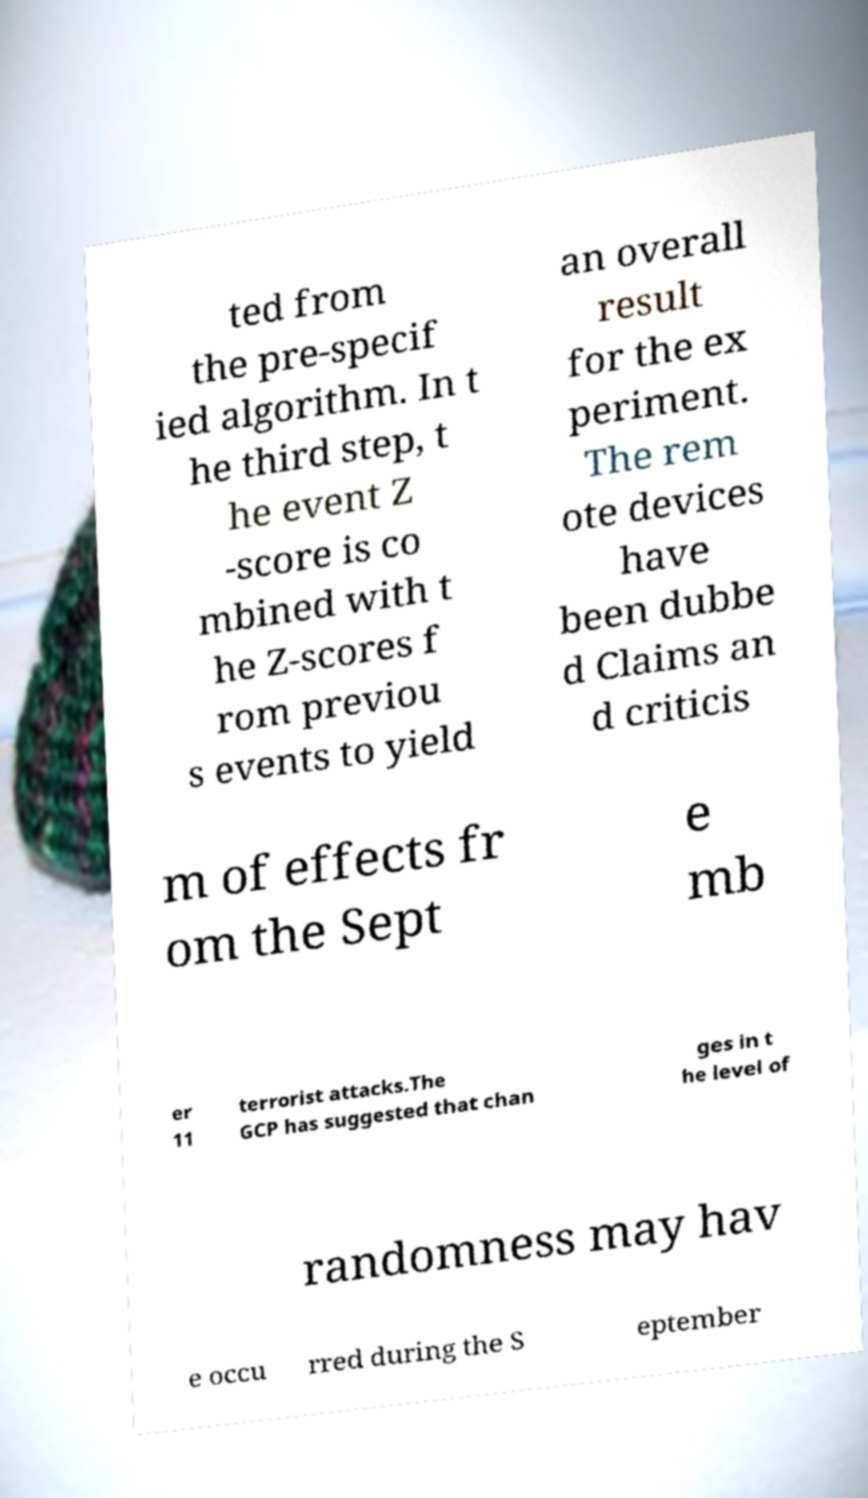Please identify and transcribe the text found in this image. ted from the pre-specif ied algorithm. In t he third step, t he event Z -score is co mbined with t he Z-scores f rom previou s events to yield an overall result for the ex periment. The rem ote devices have been dubbe d Claims an d criticis m of effects fr om the Sept e mb er 11 terrorist attacks.The GCP has suggested that chan ges in t he level of randomness may hav e occu rred during the S eptember 